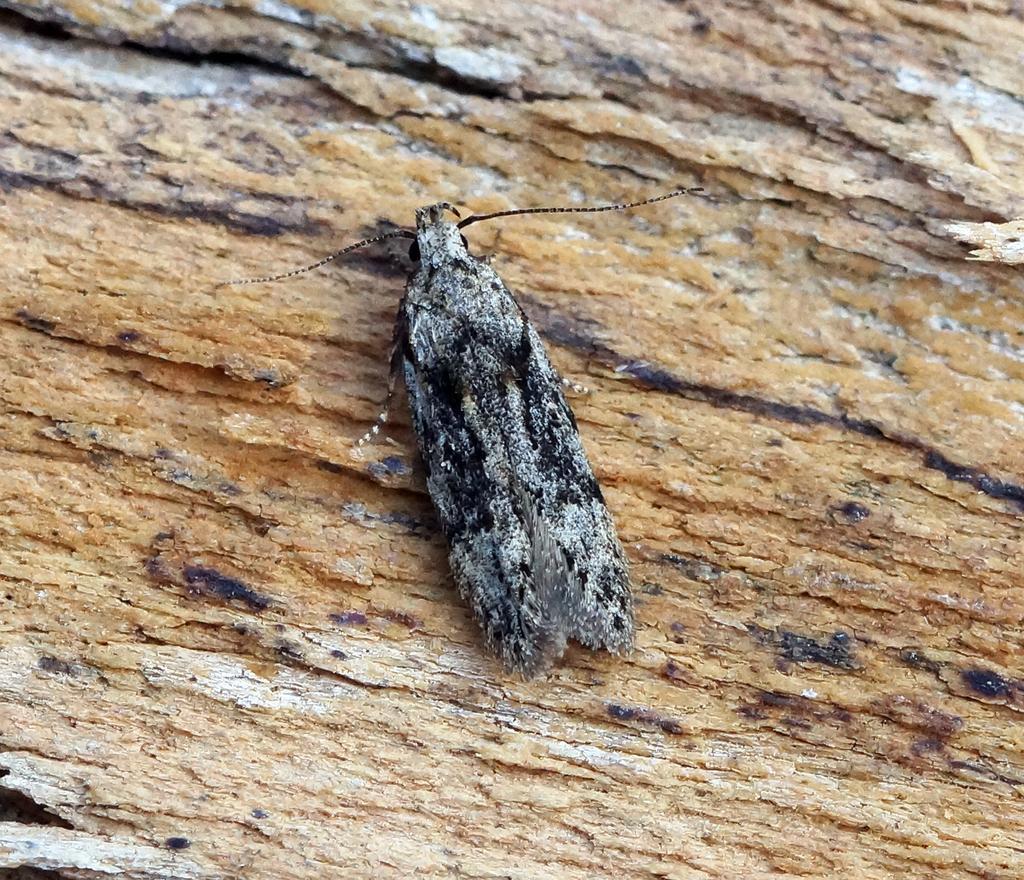Can you describe this image briefly? This picture contains an insect. It is in black color. In the background, it is brown in color. This might be the stem of the tree. 